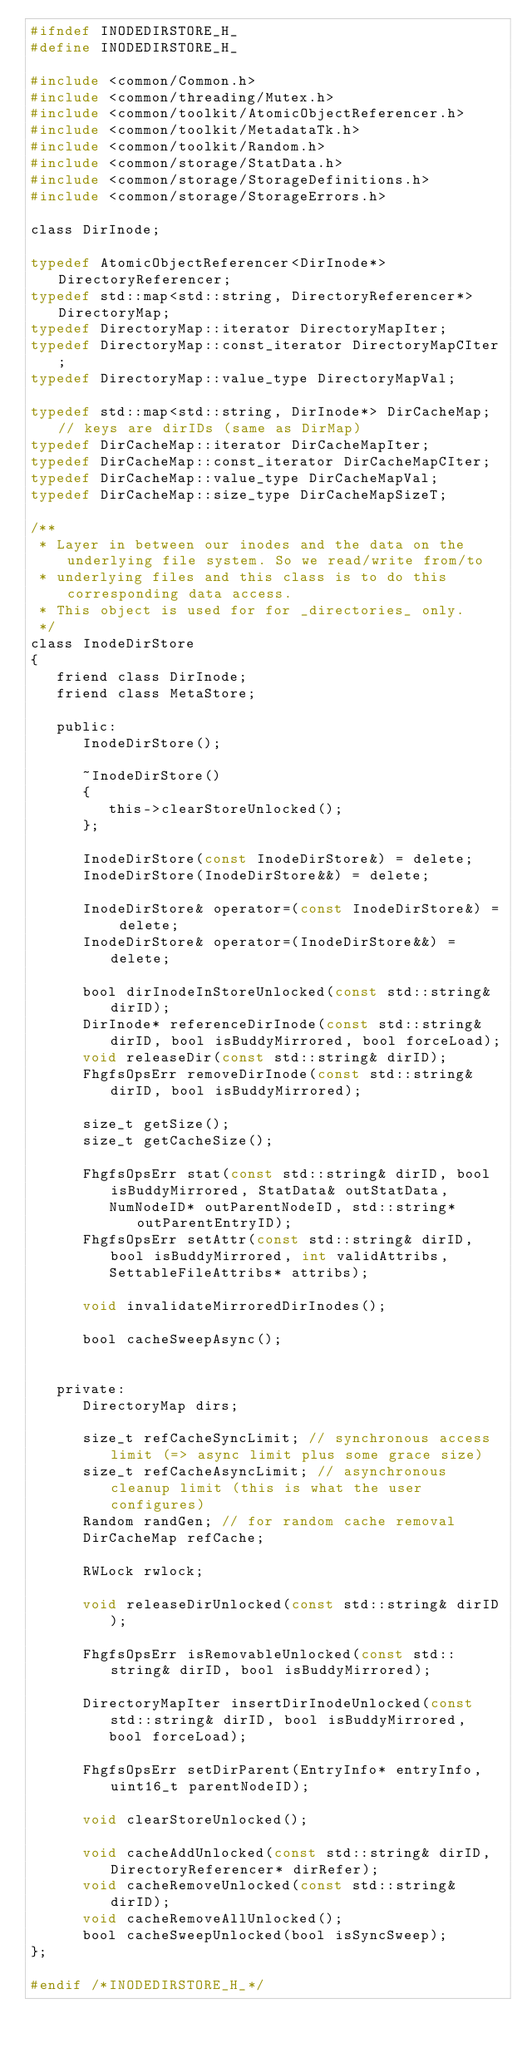<code> <loc_0><loc_0><loc_500><loc_500><_C_>#ifndef INODEDIRSTORE_H_
#define INODEDIRSTORE_H_

#include <common/Common.h>
#include <common/threading/Mutex.h>
#include <common/toolkit/AtomicObjectReferencer.h>
#include <common/toolkit/MetadataTk.h>
#include <common/toolkit/Random.h>
#include <common/storage/StatData.h>
#include <common/storage/StorageDefinitions.h>
#include <common/storage/StorageErrors.h>

class DirInode;

typedef AtomicObjectReferencer<DirInode*> DirectoryReferencer;
typedef std::map<std::string, DirectoryReferencer*> DirectoryMap;
typedef DirectoryMap::iterator DirectoryMapIter;
typedef DirectoryMap::const_iterator DirectoryMapCIter;
typedef DirectoryMap::value_type DirectoryMapVal;

typedef std::map<std::string, DirInode*> DirCacheMap; // keys are dirIDs (same as DirMap)
typedef DirCacheMap::iterator DirCacheMapIter;
typedef DirCacheMap::const_iterator DirCacheMapCIter;
typedef DirCacheMap::value_type DirCacheMapVal;
typedef DirCacheMap::size_type DirCacheMapSizeT;

/**
 * Layer in between our inodes and the data on the underlying file system. So we read/write from/to
 * underlying files and this class is to do this corresponding data access.
 * This object is used for for _directories_ only.
 */
class InodeDirStore
{
   friend class DirInode;
   friend class MetaStore;

   public:
      InodeDirStore();

      ~InodeDirStore()
      {
         this->clearStoreUnlocked();
      };

      InodeDirStore(const InodeDirStore&) = delete;
      InodeDirStore(InodeDirStore&&) = delete;

      InodeDirStore& operator=(const InodeDirStore&) = delete;
      InodeDirStore& operator=(InodeDirStore&&) = delete;

      bool dirInodeInStoreUnlocked(const std::string& dirID);
      DirInode* referenceDirInode(const std::string& dirID, bool isBuddyMirrored, bool forceLoad);
      void releaseDir(const std::string& dirID);
      FhgfsOpsErr removeDirInode(const std::string& dirID, bool isBuddyMirrored);

      size_t getSize();
      size_t getCacheSize();

      FhgfsOpsErr stat(const std::string& dirID, bool isBuddyMirrored, StatData& outStatData,
         NumNodeID* outParentNodeID, std::string* outParentEntryID);
      FhgfsOpsErr setAttr(const std::string& dirID, bool isBuddyMirrored, int validAttribs,
         SettableFileAttribs* attribs);

      void invalidateMirroredDirInodes();

      bool cacheSweepAsync();


   private:
      DirectoryMap dirs;

      size_t refCacheSyncLimit; // synchronous access limit (=> async limit plus some grace size)
      size_t refCacheAsyncLimit; // asynchronous cleanup limit (this is what the user configures)
      Random randGen; // for random cache removal
      DirCacheMap refCache;

      RWLock rwlock;

      void releaseDirUnlocked(const std::string& dirID);

      FhgfsOpsErr isRemovableUnlocked(const std::string& dirID, bool isBuddyMirrored);

      DirectoryMapIter insertDirInodeUnlocked(const std::string& dirID, bool isBuddyMirrored,
         bool forceLoad);

      FhgfsOpsErr setDirParent(EntryInfo* entryInfo, uint16_t parentNodeID);

      void clearStoreUnlocked();

      void cacheAddUnlocked(const std::string& dirID, DirectoryReferencer* dirRefer);
      void cacheRemoveUnlocked(const std::string& dirID);
      void cacheRemoveAllUnlocked();
      bool cacheSweepUnlocked(bool isSyncSweep);
};

#endif /*INODEDIRSTORE_H_*/
</code> 